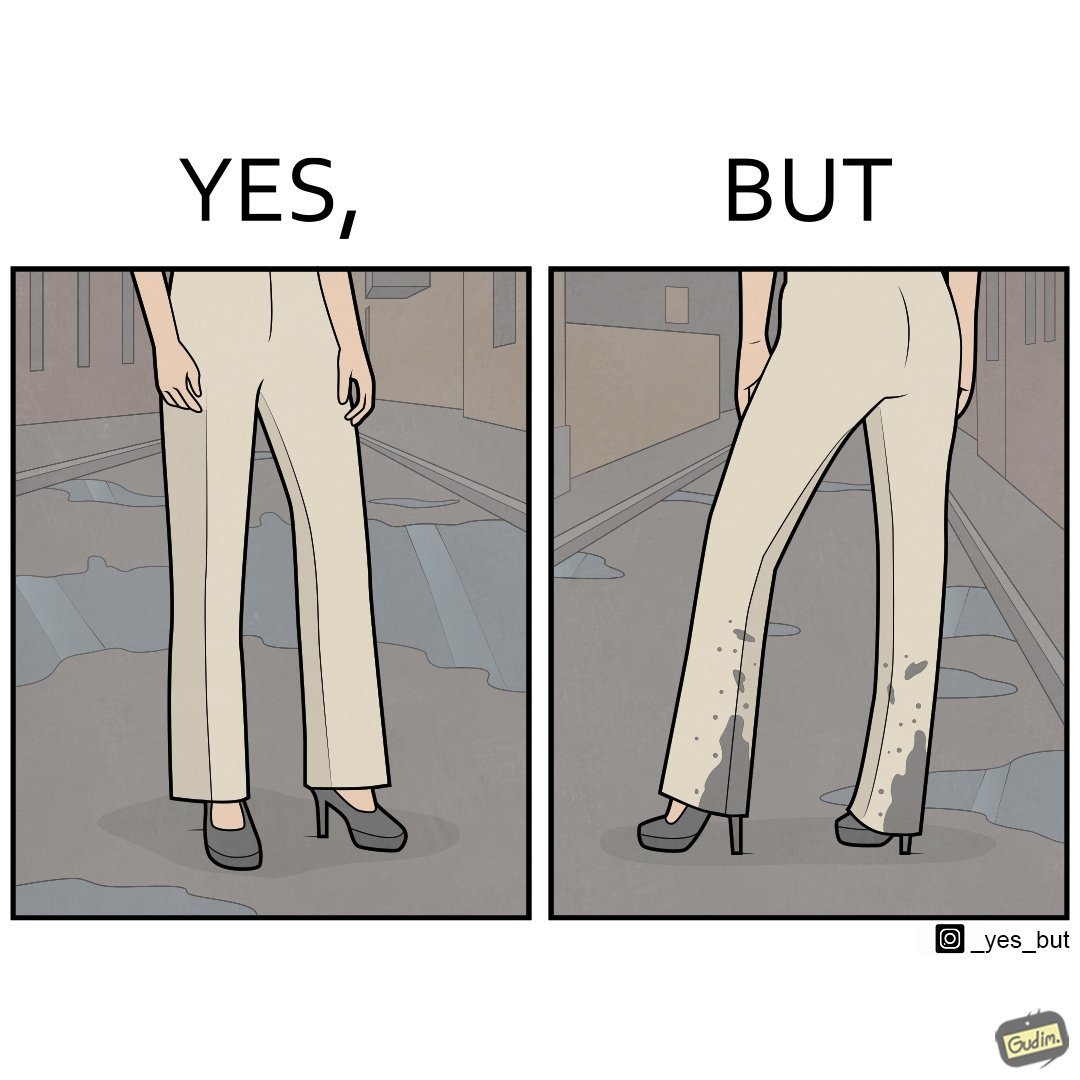What does this image depict? The image is funny, as when looking from the front, girl's pants are spick and span, while looking from the back, her pants are soaked in water, probably due to walking on a road filled with water in high heels. This is ironical, as the very reason for wearing heels (i.e. looking beautiful) is defeated, due to the heels themselves. 